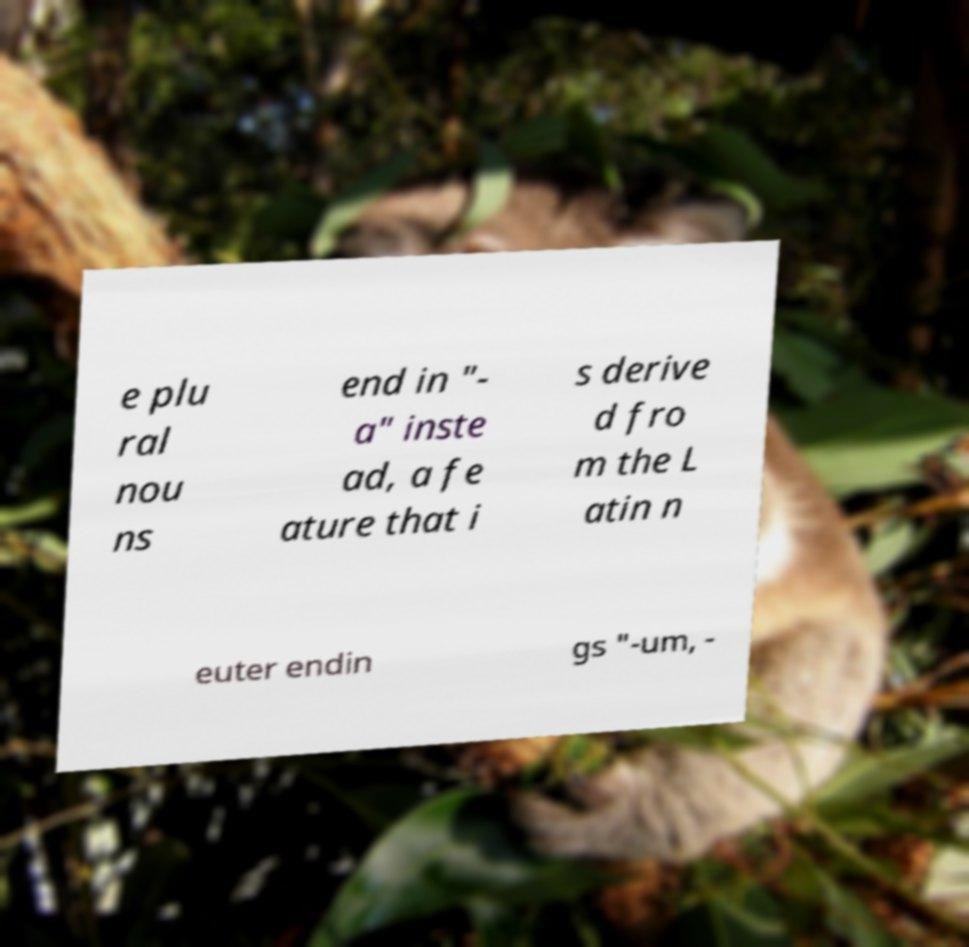Could you extract and type out the text from this image? e plu ral nou ns end in "- a" inste ad, a fe ature that i s derive d fro m the L atin n euter endin gs "-um, - 